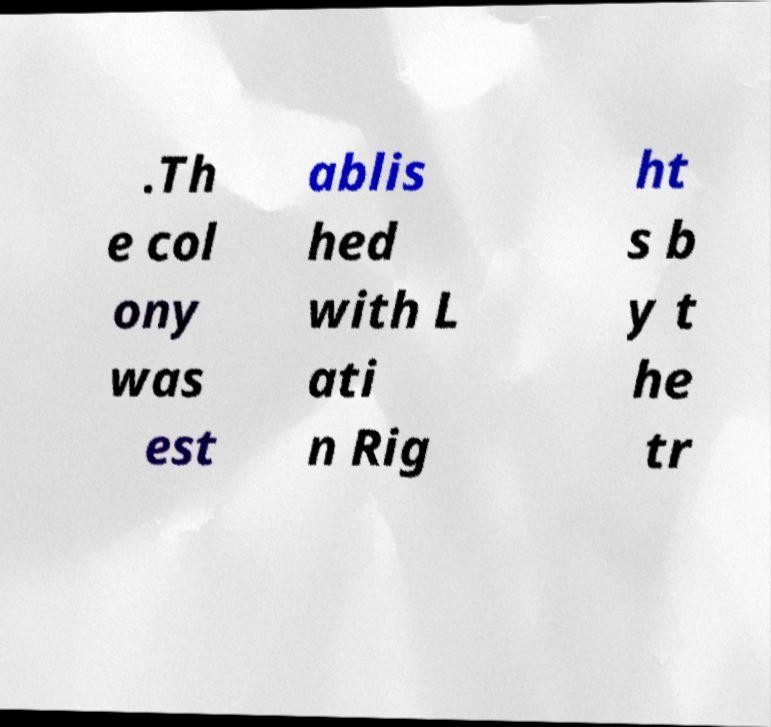Could you assist in decoding the text presented in this image and type it out clearly? .Th e col ony was est ablis hed with L ati n Rig ht s b y t he tr 